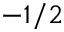<formula> <loc_0><loc_0><loc_500><loc_500>- 1 / 2</formula> 